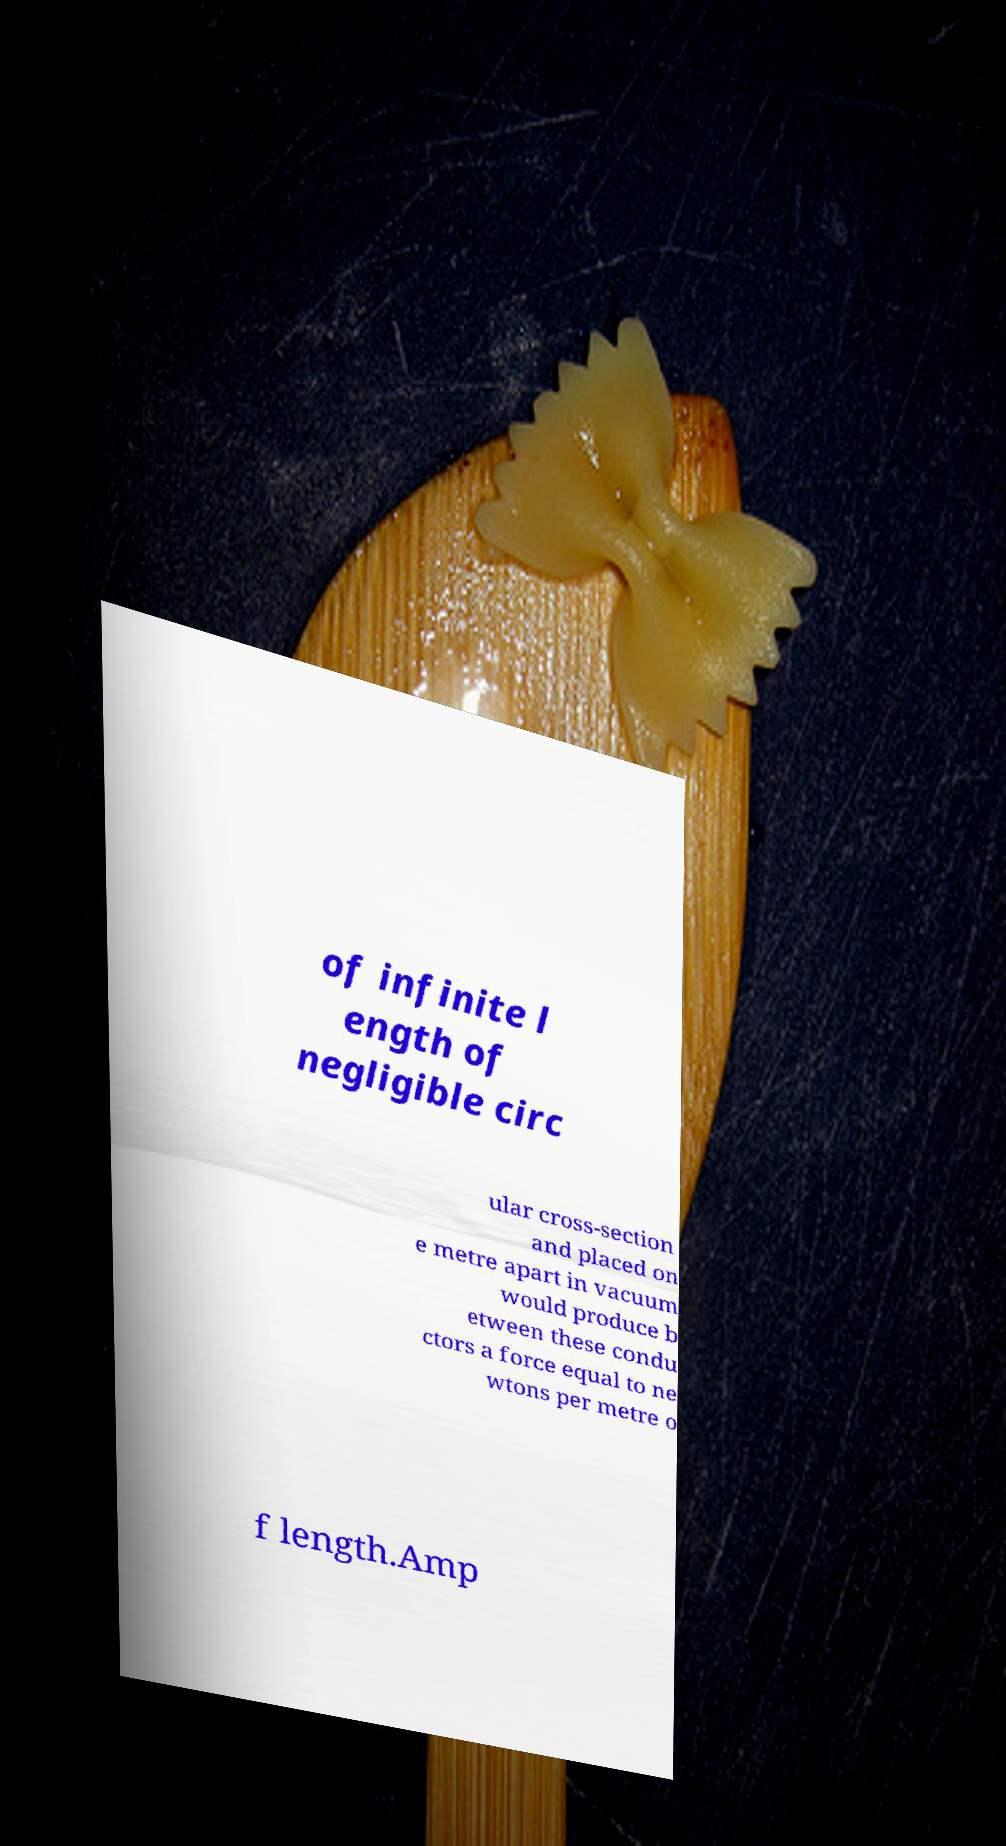There's text embedded in this image that I need extracted. Can you transcribe it verbatim? of infinite l ength of negligible circ ular cross-section and placed on e metre apart in vacuum would produce b etween these condu ctors a force equal to ne wtons per metre o f length.Amp 